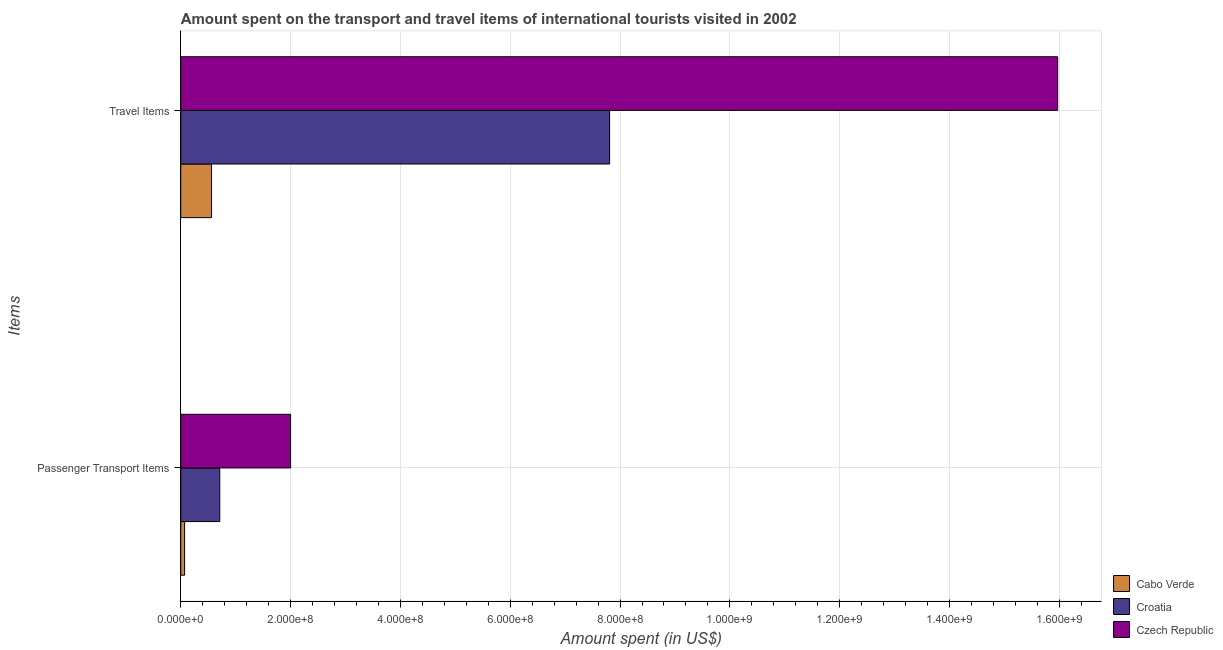How many different coloured bars are there?
Offer a terse response. 3. How many bars are there on the 1st tick from the top?
Your answer should be very brief. 3. How many bars are there on the 1st tick from the bottom?
Provide a succinct answer. 3. What is the label of the 2nd group of bars from the top?
Keep it short and to the point. Passenger Transport Items. What is the amount spent in travel items in Czech Republic?
Ensure brevity in your answer.  1.60e+09. Across all countries, what is the maximum amount spent on passenger transport items?
Ensure brevity in your answer.  2.00e+08. Across all countries, what is the minimum amount spent on passenger transport items?
Offer a very short reply. 7.00e+06. In which country was the amount spent in travel items maximum?
Your answer should be very brief. Czech Republic. In which country was the amount spent on passenger transport items minimum?
Keep it short and to the point. Cabo Verde. What is the total amount spent on passenger transport items in the graph?
Your answer should be very brief. 2.78e+08. What is the difference between the amount spent in travel items in Croatia and that in Czech Republic?
Give a very brief answer. -8.16e+08. What is the difference between the amount spent in travel items in Cabo Verde and the amount spent on passenger transport items in Croatia?
Offer a terse response. -1.50e+07. What is the average amount spent in travel items per country?
Provide a succinct answer. 8.11e+08. What is the difference between the amount spent on passenger transport items and amount spent in travel items in Czech Republic?
Your answer should be compact. -1.40e+09. What is the ratio of the amount spent on passenger transport items in Cabo Verde to that in Czech Republic?
Keep it short and to the point. 0.04. In how many countries, is the amount spent in travel items greater than the average amount spent in travel items taken over all countries?
Your answer should be compact. 1. What does the 1st bar from the top in Passenger Transport Items represents?
Ensure brevity in your answer.  Czech Republic. What does the 1st bar from the bottom in Travel Items represents?
Keep it short and to the point. Cabo Verde. Are all the bars in the graph horizontal?
Your response must be concise. Yes. How many countries are there in the graph?
Your answer should be very brief. 3. What is the difference between two consecutive major ticks on the X-axis?
Give a very brief answer. 2.00e+08. Does the graph contain grids?
Ensure brevity in your answer.  Yes. How many legend labels are there?
Offer a terse response. 3. What is the title of the graph?
Your answer should be very brief. Amount spent on the transport and travel items of international tourists visited in 2002. Does "Botswana" appear as one of the legend labels in the graph?
Offer a very short reply. No. What is the label or title of the X-axis?
Give a very brief answer. Amount spent (in US$). What is the label or title of the Y-axis?
Offer a very short reply. Items. What is the Amount spent (in US$) of Cabo Verde in Passenger Transport Items?
Make the answer very short. 7.00e+06. What is the Amount spent (in US$) of Croatia in Passenger Transport Items?
Your answer should be very brief. 7.10e+07. What is the Amount spent (in US$) of Cabo Verde in Travel Items?
Provide a short and direct response. 5.60e+07. What is the Amount spent (in US$) in Croatia in Travel Items?
Keep it short and to the point. 7.81e+08. What is the Amount spent (in US$) in Czech Republic in Travel Items?
Your response must be concise. 1.60e+09. Across all Items, what is the maximum Amount spent (in US$) in Cabo Verde?
Provide a succinct answer. 5.60e+07. Across all Items, what is the maximum Amount spent (in US$) in Croatia?
Keep it short and to the point. 7.81e+08. Across all Items, what is the maximum Amount spent (in US$) in Czech Republic?
Your answer should be compact. 1.60e+09. Across all Items, what is the minimum Amount spent (in US$) of Croatia?
Offer a terse response. 7.10e+07. What is the total Amount spent (in US$) of Cabo Verde in the graph?
Provide a succinct answer. 6.30e+07. What is the total Amount spent (in US$) of Croatia in the graph?
Give a very brief answer. 8.52e+08. What is the total Amount spent (in US$) in Czech Republic in the graph?
Ensure brevity in your answer.  1.80e+09. What is the difference between the Amount spent (in US$) in Cabo Verde in Passenger Transport Items and that in Travel Items?
Provide a succinct answer. -4.90e+07. What is the difference between the Amount spent (in US$) in Croatia in Passenger Transport Items and that in Travel Items?
Offer a very short reply. -7.10e+08. What is the difference between the Amount spent (in US$) in Czech Republic in Passenger Transport Items and that in Travel Items?
Ensure brevity in your answer.  -1.40e+09. What is the difference between the Amount spent (in US$) in Cabo Verde in Passenger Transport Items and the Amount spent (in US$) in Croatia in Travel Items?
Make the answer very short. -7.74e+08. What is the difference between the Amount spent (in US$) of Cabo Verde in Passenger Transport Items and the Amount spent (in US$) of Czech Republic in Travel Items?
Your answer should be compact. -1.59e+09. What is the difference between the Amount spent (in US$) in Croatia in Passenger Transport Items and the Amount spent (in US$) in Czech Republic in Travel Items?
Provide a short and direct response. -1.53e+09. What is the average Amount spent (in US$) in Cabo Verde per Items?
Your response must be concise. 3.15e+07. What is the average Amount spent (in US$) in Croatia per Items?
Ensure brevity in your answer.  4.26e+08. What is the average Amount spent (in US$) in Czech Republic per Items?
Your response must be concise. 8.98e+08. What is the difference between the Amount spent (in US$) of Cabo Verde and Amount spent (in US$) of Croatia in Passenger Transport Items?
Provide a succinct answer. -6.40e+07. What is the difference between the Amount spent (in US$) of Cabo Verde and Amount spent (in US$) of Czech Republic in Passenger Transport Items?
Provide a succinct answer. -1.93e+08. What is the difference between the Amount spent (in US$) in Croatia and Amount spent (in US$) in Czech Republic in Passenger Transport Items?
Offer a very short reply. -1.29e+08. What is the difference between the Amount spent (in US$) of Cabo Verde and Amount spent (in US$) of Croatia in Travel Items?
Keep it short and to the point. -7.25e+08. What is the difference between the Amount spent (in US$) of Cabo Verde and Amount spent (in US$) of Czech Republic in Travel Items?
Your answer should be compact. -1.54e+09. What is the difference between the Amount spent (in US$) of Croatia and Amount spent (in US$) of Czech Republic in Travel Items?
Give a very brief answer. -8.16e+08. What is the ratio of the Amount spent (in US$) in Cabo Verde in Passenger Transport Items to that in Travel Items?
Provide a succinct answer. 0.12. What is the ratio of the Amount spent (in US$) in Croatia in Passenger Transport Items to that in Travel Items?
Ensure brevity in your answer.  0.09. What is the ratio of the Amount spent (in US$) of Czech Republic in Passenger Transport Items to that in Travel Items?
Give a very brief answer. 0.13. What is the difference between the highest and the second highest Amount spent (in US$) of Cabo Verde?
Ensure brevity in your answer.  4.90e+07. What is the difference between the highest and the second highest Amount spent (in US$) of Croatia?
Offer a terse response. 7.10e+08. What is the difference between the highest and the second highest Amount spent (in US$) in Czech Republic?
Make the answer very short. 1.40e+09. What is the difference between the highest and the lowest Amount spent (in US$) of Cabo Verde?
Keep it short and to the point. 4.90e+07. What is the difference between the highest and the lowest Amount spent (in US$) in Croatia?
Provide a succinct answer. 7.10e+08. What is the difference between the highest and the lowest Amount spent (in US$) in Czech Republic?
Your answer should be compact. 1.40e+09. 